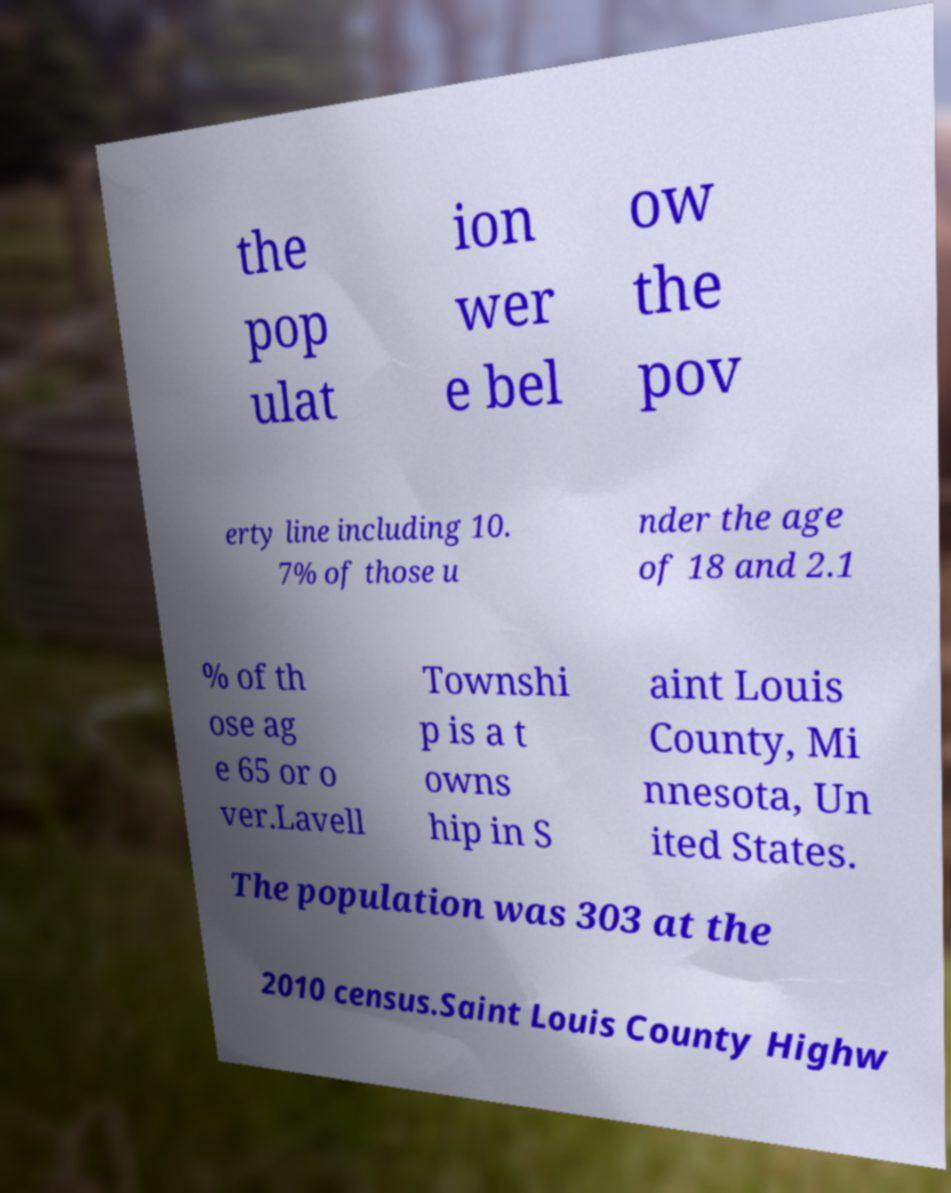Can you accurately transcribe the text from the provided image for me? the pop ulat ion wer e bel ow the pov erty line including 10. 7% of those u nder the age of 18 and 2.1 % of th ose ag e 65 or o ver.Lavell Townshi p is a t owns hip in S aint Louis County, Mi nnesota, Un ited States. The population was 303 at the 2010 census.Saint Louis County Highw 